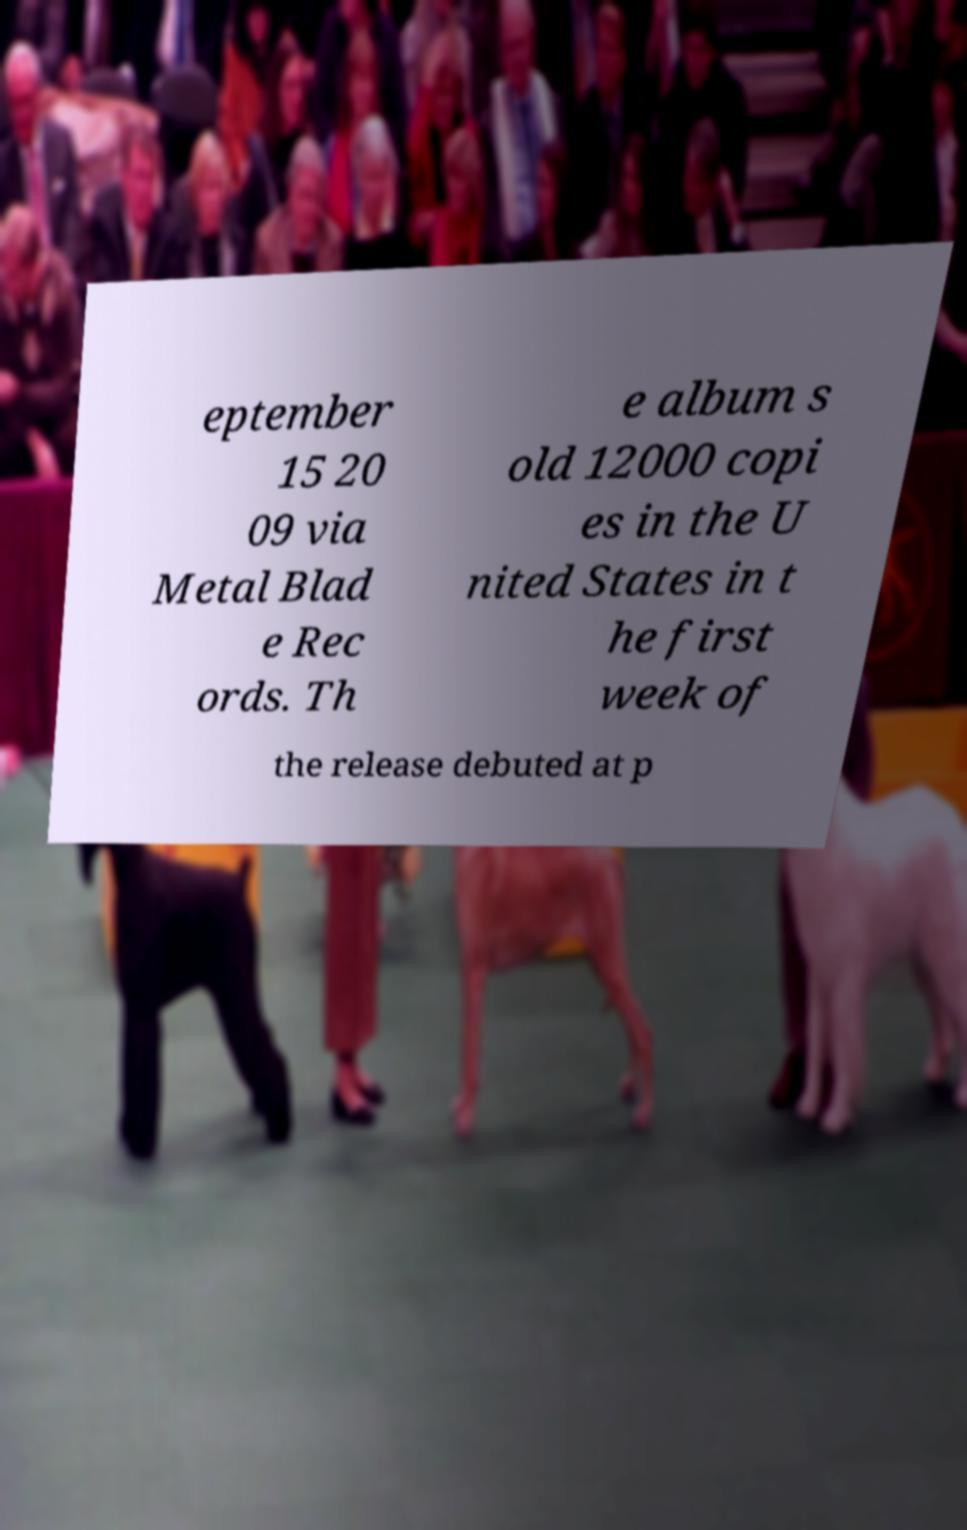For documentation purposes, I need the text within this image transcribed. Could you provide that? eptember 15 20 09 via Metal Blad e Rec ords. Th e album s old 12000 copi es in the U nited States in t he first week of the release debuted at p 